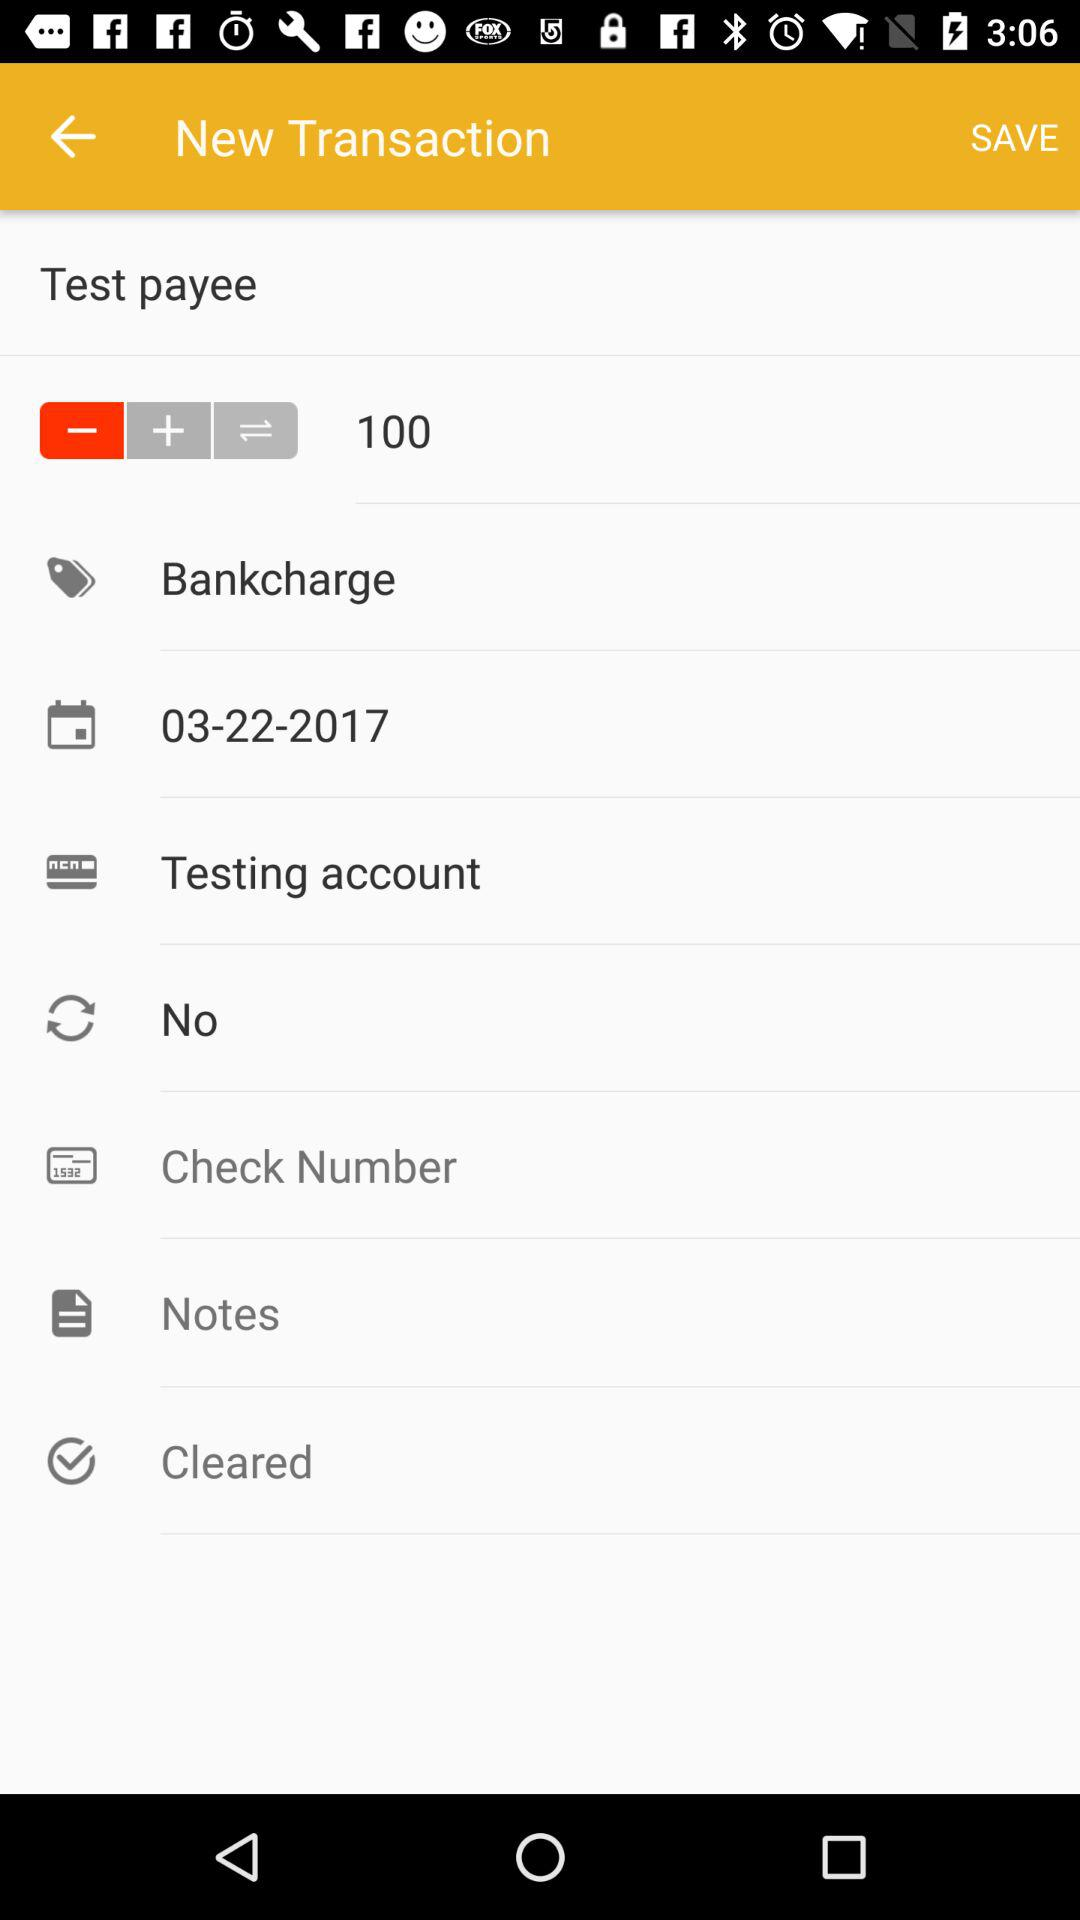What is the date of the transaction?
Answer the question using a single word or phrase. 03-22-2017 